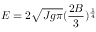<formula> <loc_0><loc_0><loc_500><loc_500>E = 2 \sqrt { J g \pi } ( \frac { 2 B } { 3 } ) ^ { \frac { 1 } { 4 } }</formula> 